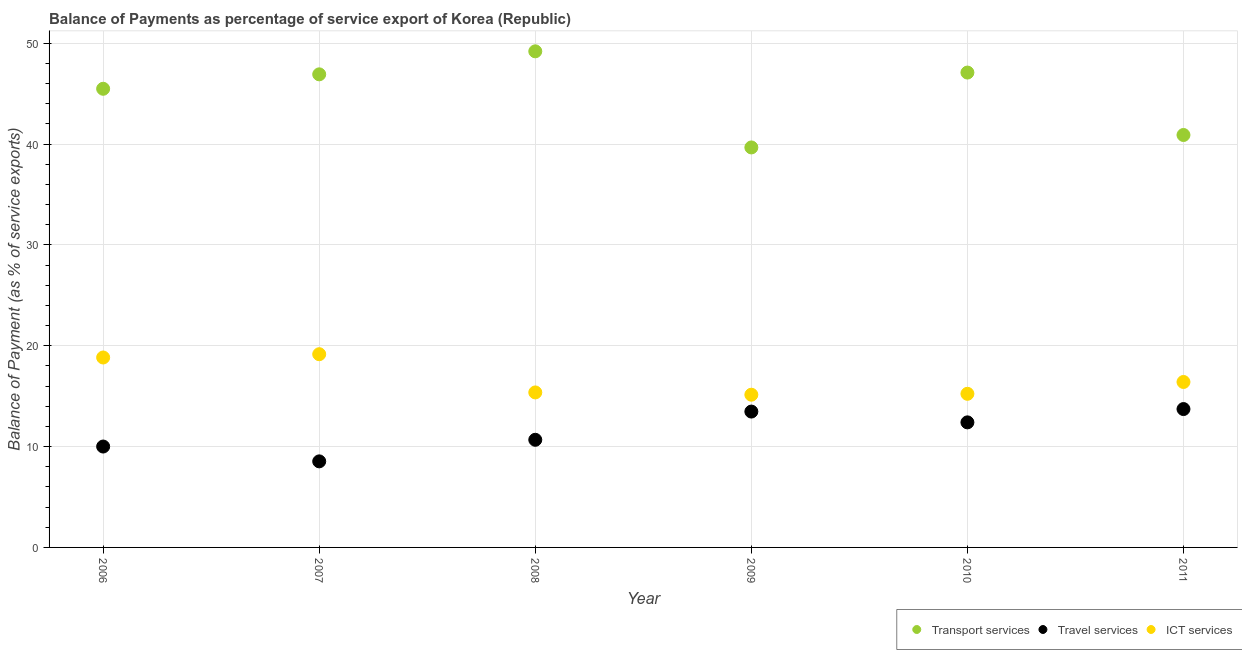How many different coloured dotlines are there?
Offer a terse response. 3. Is the number of dotlines equal to the number of legend labels?
Keep it short and to the point. Yes. What is the balance of payment of transport services in 2011?
Your answer should be compact. 40.91. Across all years, what is the maximum balance of payment of ict services?
Make the answer very short. 19.16. Across all years, what is the minimum balance of payment of ict services?
Your answer should be very brief. 15.15. In which year was the balance of payment of travel services maximum?
Ensure brevity in your answer.  2011. In which year was the balance of payment of ict services minimum?
Give a very brief answer. 2009. What is the total balance of payment of ict services in the graph?
Your answer should be compact. 100.17. What is the difference between the balance of payment of ict services in 2006 and that in 2008?
Give a very brief answer. 3.46. What is the difference between the balance of payment of travel services in 2006 and the balance of payment of ict services in 2009?
Give a very brief answer. -5.14. What is the average balance of payment of transport services per year?
Keep it short and to the point. 44.88. In the year 2010, what is the difference between the balance of payment of ict services and balance of payment of transport services?
Your answer should be very brief. -31.86. What is the ratio of the balance of payment of ict services in 2007 to that in 2009?
Provide a succinct answer. 1.27. Is the difference between the balance of payment of ict services in 2008 and 2010 greater than the difference between the balance of payment of travel services in 2008 and 2010?
Your response must be concise. Yes. What is the difference between the highest and the second highest balance of payment of travel services?
Make the answer very short. 0.25. What is the difference between the highest and the lowest balance of payment of travel services?
Provide a short and direct response. 5.19. Is the sum of the balance of payment of transport services in 2006 and 2009 greater than the maximum balance of payment of travel services across all years?
Give a very brief answer. Yes. Is it the case that in every year, the sum of the balance of payment of transport services and balance of payment of travel services is greater than the balance of payment of ict services?
Offer a very short reply. Yes. Is the balance of payment of ict services strictly greater than the balance of payment of transport services over the years?
Make the answer very short. No. Is the balance of payment of ict services strictly less than the balance of payment of travel services over the years?
Provide a succinct answer. No. How many years are there in the graph?
Offer a very short reply. 6. What is the difference between two consecutive major ticks on the Y-axis?
Your answer should be compact. 10. Are the values on the major ticks of Y-axis written in scientific E-notation?
Your answer should be very brief. No. Does the graph contain any zero values?
Offer a very short reply. No. Does the graph contain grids?
Offer a very short reply. Yes. Where does the legend appear in the graph?
Offer a terse response. Bottom right. How many legend labels are there?
Your answer should be compact. 3. How are the legend labels stacked?
Offer a terse response. Horizontal. What is the title of the graph?
Offer a very short reply. Balance of Payments as percentage of service export of Korea (Republic). Does "Oil" appear as one of the legend labels in the graph?
Your response must be concise. No. What is the label or title of the Y-axis?
Provide a succinct answer. Balance of Payment (as % of service exports). What is the Balance of Payment (as % of service exports) in Transport services in 2006?
Ensure brevity in your answer.  45.49. What is the Balance of Payment (as % of service exports) of Travel services in 2006?
Offer a very short reply. 10.01. What is the Balance of Payment (as % of service exports) in ICT services in 2006?
Provide a short and direct response. 18.84. What is the Balance of Payment (as % of service exports) of Transport services in 2007?
Provide a short and direct response. 46.92. What is the Balance of Payment (as % of service exports) of Travel services in 2007?
Ensure brevity in your answer.  8.54. What is the Balance of Payment (as % of service exports) in ICT services in 2007?
Your response must be concise. 19.16. What is the Balance of Payment (as % of service exports) of Transport services in 2008?
Provide a succinct answer. 49.21. What is the Balance of Payment (as % of service exports) of Travel services in 2008?
Ensure brevity in your answer.  10.68. What is the Balance of Payment (as % of service exports) of ICT services in 2008?
Offer a very short reply. 15.37. What is the Balance of Payment (as % of service exports) in Transport services in 2009?
Your answer should be very brief. 39.67. What is the Balance of Payment (as % of service exports) of Travel services in 2009?
Provide a short and direct response. 13.48. What is the Balance of Payment (as % of service exports) of ICT services in 2009?
Your answer should be compact. 15.15. What is the Balance of Payment (as % of service exports) of Transport services in 2010?
Ensure brevity in your answer.  47.1. What is the Balance of Payment (as % of service exports) of Travel services in 2010?
Your answer should be compact. 12.4. What is the Balance of Payment (as % of service exports) of ICT services in 2010?
Provide a succinct answer. 15.24. What is the Balance of Payment (as % of service exports) of Transport services in 2011?
Offer a very short reply. 40.91. What is the Balance of Payment (as % of service exports) of Travel services in 2011?
Offer a very short reply. 13.72. What is the Balance of Payment (as % of service exports) of ICT services in 2011?
Offer a terse response. 16.41. Across all years, what is the maximum Balance of Payment (as % of service exports) of Transport services?
Offer a terse response. 49.21. Across all years, what is the maximum Balance of Payment (as % of service exports) in Travel services?
Keep it short and to the point. 13.72. Across all years, what is the maximum Balance of Payment (as % of service exports) of ICT services?
Offer a terse response. 19.16. Across all years, what is the minimum Balance of Payment (as % of service exports) in Transport services?
Make the answer very short. 39.67. Across all years, what is the minimum Balance of Payment (as % of service exports) in Travel services?
Your answer should be very brief. 8.54. Across all years, what is the minimum Balance of Payment (as % of service exports) in ICT services?
Offer a terse response. 15.15. What is the total Balance of Payment (as % of service exports) of Transport services in the graph?
Offer a terse response. 269.3. What is the total Balance of Payment (as % of service exports) in Travel services in the graph?
Give a very brief answer. 68.82. What is the total Balance of Payment (as % of service exports) of ICT services in the graph?
Offer a terse response. 100.17. What is the difference between the Balance of Payment (as % of service exports) in Transport services in 2006 and that in 2007?
Offer a very short reply. -1.43. What is the difference between the Balance of Payment (as % of service exports) of Travel services in 2006 and that in 2007?
Provide a succinct answer. 1.47. What is the difference between the Balance of Payment (as % of service exports) in ICT services in 2006 and that in 2007?
Ensure brevity in your answer.  -0.33. What is the difference between the Balance of Payment (as % of service exports) of Transport services in 2006 and that in 2008?
Give a very brief answer. -3.71. What is the difference between the Balance of Payment (as % of service exports) in Travel services in 2006 and that in 2008?
Offer a very short reply. -0.67. What is the difference between the Balance of Payment (as % of service exports) of ICT services in 2006 and that in 2008?
Offer a very short reply. 3.46. What is the difference between the Balance of Payment (as % of service exports) in Transport services in 2006 and that in 2009?
Provide a short and direct response. 5.82. What is the difference between the Balance of Payment (as % of service exports) of Travel services in 2006 and that in 2009?
Your response must be concise. -3.47. What is the difference between the Balance of Payment (as % of service exports) in ICT services in 2006 and that in 2009?
Provide a succinct answer. 3.69. What is the difference between the Balance of Payment (as % of service exports) of Transport services in 2006 and that in 2010?
Your response must be concise. -1.61. What is the difference between the Balance of Payment (as % of service exports) of Travel services in 2006 and that in 2010?
Provide a succinct answer. -2.4. What is the difference between the Balance of Payment (as % of service exports) of ICT services in 2006 and that in 2010?
Ensure brevity in your answer.  3.6. What is the difference between the Balance of Payment (as % of service exports) of Transport services in 2006 and that in 2011?
Your answer should be compact. 4.58. What is the difference between the Balance of Payment (as % of service exports) of Travel services in 2006 and that in 2011?
Keep it short and to the point. -3.72. What is the difference between the Balance of Payment (as % of service exports) of ICT services in 2006 and that in 2011?
Your answer should be compact. 2.43. What is the difference between the Balance of Payment (as % of service exports) of Transport services in 2007 and that in 2008?
Give a very brief answer. -2.28. What is the difference between the Balance of Payment (as % of service exports) in Travel services in 2007 and that in 2008?
Offer a terse response. -2.14. What is the difference between the Balance of Payment (as % of service exports) in ICT services in 2007 and that in 2008?
Offer a terse response. 3.79. What is the difference between the Balance of Payment (as % of service exports) of Transport services in 2007 and that in 2009?
Offer a very short reply. 7.25. What is the difference between the Balance of Payment (as % of service exports) of Travel services in 2007 and that in 2009?
Your answer should be compact. -4.94. What is the difference between the Balance of Payment (as % of service exports) in ICT services in 2007 and that in 2009?
Your answer should be compact. 4.02. What is the difference between the Balance of Payment (as % of service exports) of Transport services in 2007 and that in 2010?
Your answer should be compact. -0.18. What is the difference between the Balance of Payment (as % of service exports) in Travel services in 2007 and that in 2010?
Offer a very short reply. -3.87. What is the difference between the Balance of Payment (as % of service exports) of ICT services in 2007 and that in 2010?
Ensure brevity in your answer.  3.93. What is the difference between the Balance of Payment (as % of service exports) in Transport services in 2007 and that in 2011?
Offer a terse response. 6.02. What is the difference between the Balance of Payment (as % of service exports) of Travel services in 2007 and that in 2011?
Your answer should be very brief. -5.19. What is the difference between the Balance of Payment (as % of service exports) of ICT services in 2007 and that in 2011?
Ensure brevity in your answer.  2.76. What is the difference between the Balance of Payment (as % of service exports) in Transport services in 2008 and that in 2009?
Give a very brief answer. 9.53. What is the difference between the Balance of Payment (as % of service exports) in Travel services in 2008 and that in 2009?
Your answer should be very brief. -2.8. What is the difference between the Balance of Payment (as % of service exports) of ICT services in 2008 and that in 2009?
Provide a short and direct response. 0.23. What is the difference between the Balance of Payment (as % of service exports) of Transport services in 2008 and that in 2010?
Your answer should be very brief. 2.11. What is the difference between the Balance of Payment (as % of service exports) of Travel services in 2008 and that in 2010?
Offer a terse response. -1.73. What is the difference between the Balance of Payment (as % of service exports) of ICT services in 2008 and that in 2010?
Provide a succinct answer. 0.14. What is the difference between the Balance of Payment (as % of service exports) in Transport services in 2008 and that in 2011?
Offer a very short reply. 8.3. What is the difference between the Balance of Payment (as % of service exports) of Travel services in 2008 and that in 2011?
Your answer should be compact. -3.05. What is the difference between the Balance of Payment (as % of service exports) of ICT services in 2008 and that in 2011?
Your answer should be compact. -1.04. What is the difference between the Balance of Payment (as % of service exports) in Transport services in 2009 and that in 2010?
Keep it short and to the point. -7.43. What is the difference between the Balance of Payment (as % of service exports) of Travel services in 2009 and that in 2010?
Make the answer very short. 1.07. What is the difference between the Balance of Payment (as % of service exports) in ICT services in 2009 and that in 2010?
Provide a succinct answer. -0.09. What is the difference between the Balance of Payment (as % of service exports) in Transport services in 2009 and that in 2011?
Your response must be concise. -1.23. What is the difference between the Balance of Payment (as % of service exports) of Travel services in 2009 and that in 2011?
Give a very brief answer. -0.25. What is the difference between the Balance of Payment (as % of service exports) of ICT services in 2009 and that in 2011?
Offer a terse response. -1.26. What is the difference between the Balance of Payment (as % of service exports) in Transport services in 2010 and that in 2011?
Your answer should be very brief. 6.19. What is the difference between the Balance of Payment (as % of service exports) of Travel services in 2010 and that in 2011?
Give a very brief answer. -1.32. What is the difference between the Balance of Payment (as % of service exports) of ICT services in 2010 and that in 2011?
Your response must be concise. -1.17. What is the difference between the Balance of Payment (as % of service exports) of Transport services in 2006 and the Balance of Payment (as % of service exports) of Travel services in 2007?
Offer a terse response. 36.96. What is the difference between the Balance of Payment (as % of service exports) in Transport services in 2006 and the Balance of Payment (as % of service exports) in ICT services in 2007?
Provide a succinct answer. 26.33. What is the difference between the Balance of Payment (as % of service exports) of Travel services in 2006 and the Balance of Payment (as % of service exports) of ICT services in 2007?
Provide a short and direct response. -9.16. What is the difference between the Balance of Payment (as % of service exports) of Transport services in 2006 and the Balance of Payment (as % of service exports) of Travel services in 2008?
Offer a very short reply. 34.82. What is the difference between the Balance of Payment (as % of service exports) of Transport services in 2006 and the Balance of Payment (as % of service exports) of ICT services in 2008?
Your answer should be very brief. 30.12. What is the difference between the Balance of Payment (as % of service exports) of Travel services in 2006 and the Balance of Payment (as % of service exports) of ICT services in 2008?
Offer a terse response. -5.37. What is the difference between the Balance of Payment (as % of service exports) of Transport services in 2006 and the Balance of Payment (as % of service exports) of Travel services in 2009?
Give a very brief answer. 32.02. What is the difference between the Balance of Payment (as % of service exports) of Transport services in 2006 and the Balance of Payment (as % of service exports) of ICT services in 2009?
Provide a short and direct response. 30.34. What is the difference between the Balance of Payment (as % of service exports) in Travel services in 2006 and the Balance of Payment (as % of service exports) in ICT services in 2009?
Offer a very short reply. -5.14. What is the difference between the Balance of Payment (as % of service exports) in Transport services in 2006 and the Balance of Payment (as % of service exports) in Travel services in 2010?
Offer a very short reply. 33.09. What is the difference between the Balance of Payment (as % of service exports) of Transport services in 2006 and the Balance of Payment (as % of service exports) of ICT services in 2010?
Offer a very short reply. 30.25. What is the difference between the Balance of Payment (as % of service exports) of Travel services in 2006 and the Balance of Payment (as % of service exports) of ICT services in 2010?
Your response must be concise. -5.23. What is the difference between the Balance of Payment (as % of service exports) in Transport services in 2006 and the Balance of Payment (as % of service exports) in Travel services in 2011?
Your answer should be very brief. 31.77. What is the difference between the Balance of Payment (as % of service exports) of Transport services in 2006 and the Balance of Payment (as % of service exports) of ICT services in 2011?
Your answer should be compact. 29.08. What is the difference between the Balance of Payment (as % of service exports) of Travel services in 2006 and the Balance of Payment (as % of service exports) of ICT services in 2011?
Provide a succinct answer. -6.4. What is the difference between the Balance of Payment (as % of service exports) of Transport services in 2007 and the Balance of Payment (as % of service exports) of Travel services in 2008?
Offer a very short reply. 36.25. What is the difference between the Balance of Payment (as % of service exports) in Transport services in 2007 and the Balance of Payment (as % of service exports) in ICT services in 2008?
Keep it short and to the point. 31.55. What is the difference between the Balance of Payment (as % of service exports) in Travel services in 2007 and the Balance of Payment (as % of service exports) in ICT services in 2008?
Make the answer very short. -6.84. What is the difference between the Balance of Payment (as % of service exports) of Transport services in 2007 and the Balance of Payment (as % of service exports) of Travel services in 2009?
Provide a short and direct response. 33.45. What is the difference between the Balance of Payment (as % of service exports) of Transport services in 2007 and the Balance of Payment (as % of service exports) of ICT services in 2009?
Ensure brevity in your answer.  31.78. What is the difference between the Balance of Payment (as % of service exports) of Travel services in 2007 and the Balance of Payment (as % of service exports) of ICT services in 2009?
Provide a succinct answer. -6.61. What is the difference between the Balance of Payment (as % of service exports) of Transport services in 2007 and the Balance of Payment (as % of service exports) of Travel services in 2010?
Give a very brief answer. 34.52. What is the difference between the Balance of Payment (as % of service exports) of Transport services in 2007 and the Balance of Payment (as % of service exports) of ICT services in 2010?
Provide a succinct answer. 31.69. What is the difference between the Balance of Payment (as % of service exports) of Travel services in 2007 and the Balance of Payment (as % of service exports) of ICT services in 2010?
Your answer should be very brief. -6.7. What is the difference between the Balance of Payment (as % of service exports) of Transport services in 2007 and the Balance of Payment (as % of service exports) of Travel services in 2011?
Provide a succinct answer. 33.2. What is the difference between the Balance of Payment (as % of service exports) in Transport services in 2007 and the Balance of Payment (as % of service exports) in ICT services in 2011?
Provide a short and direct response. 30.51. What is the difference between the Balance of Payment (as % of service exports) in Travel services in 2007 and the Balance of Payment (as % of service exports) in ICT services in 2011?
Keep it short and to the point. -7.87. What is the difference between the Balance of Payment (as % of service exports) of Transport services in 2008 and the Balance of Payment (as % of service exports) of Travel services in 2009?
Offer a very short reply. 35.73. What is the difference between the Balance of Payment (as % of service exports) of Transport services in 2008 and the Balance of Payment (as % of service exports) of ICT services in 2009?
Provide a short and direct response. 34.06. What is the difference between the Balance of Payment (as % of service exports) of Travel services in 2008 and the Balance of Payment (as % of service exports) of ICT services in 2009?
Your answer should be very brief. -4.47. What is the difference between the Balance of Payment (as % of service exports) of Transport services in 2008 and the Balance of Payment (as % of service exports) of Travel services in 2010?
Give a very brief answer. 36.8. What is the difference between the Balance of Payment (as % of service exports) of Transport services in 2008 and the Balance of Payment (as % of service exports) of ICT services in 2010?
Ensure brevity in your answer.  33.97. What is the difference between the Balance of Payment (as % of service exports) in Travel services in 2008 and the Balance of Payment (as % of service exports) in ICT services in 2010?
Offer a very short reply. -4.56. What is the difference between the Balance of Payment (as % of service exports) in Transport services in 2008 and the Balance of Payment (as % of service exports) in Travel services in 2011?
Your answer should be very brief. 35.48. What is the difference between the Balance of Payment (as % of service exports) of Transport services in 2008 and the Balance of Payment (as % of service exports) of ICT services in 2011?
Provide a succinct answer. 32.8. What is the difference between the Balance of Payment (as % of service exports) of Travel services in 2008 and the Balance of Payment (as % of service exports) of ICT services in 2011?
Offer a very short reply. -5.73. What is the difference between the Balance of Payment (as % of service exports) in Transport services in 2009 and the Balance of Payment (as % of service exports) in Travel services in 2010?
Provide a succinct answer. 27.27. What is the difference between the Balance of Payment (as % of service exports) of Transport services in 2009 and the Balance of Payment (as % of service exports) of ICT services in 2010?
Make the answer very short. 24.44. What is the difference between the Balance of Payment (as % of service exports) of Travel services in 2009 and the Balance of Payment (as % of service exports) of ICT services in 2010?
Make the answer very short. -1.76. What is the difference between the Balance of Payment (as % of service exports) in Transport services in 2009 and the Balance of Payment (as % of service exports) in Travel services in 2011?
Provide a succinct answer. 25.95. What is the difference between the Balance of Payment (as % of service exports) of Transport services in 2009 and the Balance of Payment (as % of service exports) of ICT services in 2011?
Provide a short and direct response. 23.26. What is the difference between the Balance of Payment (as % of service exports) in Travel services in 2009 and the Balance of Payment (as % of service exports) in ICT services in 2011?
Keep it short and to the point. -2.93. What is the difference between the Balance of Payment (as % of service exports) in Transport services in 2010 and the Balance of Payment (as % of service exports) in Travel services in 2011?
Provide a short and direct response. 33.38. What is the difference between the Balance of Payment (as % of service exports) in Transport services in 2010 and the Balance of Payment (as % of service exports) in ICT services in 2011?
Keep it short and to the point. 30.69. What is the difference between the Balance of Payment (as % of service exports) in Travel services in 2010 and the Balance of Payment (as % of service exports) in ICT services in 2011?
Your answer should be compact. -4.01. What is the average Balance of Payment (as % of service exports) of Transport services per year?
Your answer should be very brief. 44.88. What is the average Balance of Payment (as % of service exports) in Travel services per year?
Keep it short and to the point. 11.47. What is the average Balance of Payment (as % of service exports) in ICT services per year?
Keep it short and to the point. 16.7. In the year 2006, what is the difference between the Balance of Payment (as % of service exports) in Transport services and Balance of Payment (as % of service exports) in Travel services?
Keep it short and to the point. 35.48. In the year 2006, what is the difference between the Balance of Payment (as % of service exports) of Transport services and Balance of Payment (as % of service exports) of ICT services?
Keep it short and to the point. 26.65. In the year 2006, what is the difference between the Balance of Payment (as % of service exports) of Travel services and Balance of Payment (as % of service exports) of ICT services?
Keep it short and to the point. -8.83. In the year 2007, what is the difference between the Balance of Payment (as % of service exports) of Transport services and Balance of Payment (as % of service exports) of Travel services?
Your answer should be very brief. 38.39. In the year 2007, what is the difference between the Balance of Payment (as % of service exports) of Transport services and Balance of Payment (as % of service exports) of ICT services?
Ensure brevity in your answer.  27.76. In the year 2007, what is the difference between the Balance of Payment (as % of service exports) of Travel services and Balance of Payment (as % of service exports) of ICT services?
Ensure brevity in your answer.  -10.63. In the year 2008, what is the difference between the Balance of Payment (as % of service exports) in Transport services and Balance of Payment (as % of service exports) in Travel services?
Ensure brevity in your answer.  38.53. In the year 2008, what is the difference between the Balance of Payment (as % of service exports) of Transport services and Balance of Payment (as % of service exports) of ICT services?
Your answer should be very brief. 33.83. In the year 2008, what is the difference between the Balance of Payment (as % of service exports) of Travel services and Balance of Payment (as % of service exports) of ICT services?
Provide a short and direct response. -4.7. In the year 2009, what is the difference between the Balance of Payment (as % of service exports) of Transport services and Balance of Payment (as % of service exports) of Travel services?
Make the answer very short. 26.2. In the year 2009, what is the difference between the Balance of Payment (as % of service exports) of Transport services and Balance of Payment (as % of service exports) of ICT services?
Provide a succinct answer. 24.53. In the year 2009, what is the difference between the Balance of Payment (as % of service exports) in Travel services and Balance of Payment (as % of service exports) in ICT services?
Offer a terse response. -1.67. In the year 2010, what is the difference between the Balance of Payment (as % of service exports) in Transport services and Balance of Payment (as % of service exports) in Travel services?
Provide a short and direct response. 34.7. In the year 2010, what is the difference between the Balance of Payment (as % of service exports) of Transport services and Balance of Payment (as % of service exports) of ICT services?
Provide a succinct answer. 31.86. In the year 2010, what is the difference between the Balance of Payment (as % of service exports) in Travel services and Balance of Payment (as % of service exports) in ICT services?
Keep it short and to the point. -2.83. In the year 2011, what is the difference between the Balance of Payment (as % of service exports) of Transport services and Balance of Payment (as % of service exports) of Travel services?
Your response must be concise. 27.18. In the year 2011, what is the difference between the Balance of Payment (as % of service exports) of Transport services and Balance of Payment (as % of service exports) of ICT services?
Make the answer very short. 24.5. In the year 2011, what is the difference between the Balance of Payment (as % of service exports) of Travel services and Balance of Payment (as % of service exports) of ICT services?
Your response must be concise. -2.69. What is the ratio of the Balance of Payment (as % of service exports) in Transport services in 2006 to that in 2007?
Your response must be concise. 0.97. What is the ratio of the Balance of Payment (as % of service exports) of Travel services in 2006 to that in 2007?
Ensure brevity in your answer.  1.17. What is the ratio of the Balance of Payment (as % of service exports) of ICT services in 2006 to that in 2007?
Provide a short and direct response. 0.98. What is the ratio of the Balance of Payment (as % of service exports) in Transport services in 2006 to that in 2008?
Your answer should be very brief. 0.92. What is the ratio of the Balance of Payment (as % of service exports) of Travel services in 2006 to that in 2008?
Ensure brevity in your answer.  0.94. What is the ratio of the Balance of Payment (as % of service exports) in ICT services in 2006 to that in 2008?
Provide a succinct answer. 1.23. What is the ratio of the Balance of Payment (as % of service exports) in Transport services in 2006 to that in 2009?
Provide a short and direct response. 1.15. What is the ratio of the Balance of Payment (as % of service exports) of Travel services in 2006 to that in 2009?
Provide a short and direct response. 0.74. What is the ratio of the Balance of Payment (as % of service exports) of ICT services in 2006 to that in 2009?
Your answer should be very brief. 1.24. What is the ratio of the Balance of Payment (as % of service exports) in Transport services in 2006 to that in 2010?
Offer a very short reply. 0.97. What is the ratio of the Balance of Payment (as % of service exports) in Travel services in 2006 to that in 2010?
Offer a terse response. 0.81. What is the ratio of the Balance of Payment (as % of service exports) in ICT services in 2006 to that in 2010?
Ensure brevity in your answer.  1.24. What is the ratio of the Balance of Payment (as % of service exports) of Transport services in 2006 to that in 2011?
Offer a very short reply. 1.11. What is the ratio of the Balance of Payment (as % of service exports) in Travel services in 2006 to that in 2011?
Keep it short and to the point. 0.73. What is the ratio of the Balance of Payment (as % of service exports) of ICT services in 2006 to that in 2011?
Offer a very short reply. 1.15. What is the ratio of the Balance of Payment (as % of service exports) of Transport services in 2007 to that in 2008?
Offer a very short reply. 0.95. What is the ratio of the Balance of Payment (as % of service exports) in Travel services in 2007 to that in 2008?
Ensure brevity in your answer.  0.8. What is the ratio of the Balance of Payment (as % of service exports) of ICT services in 2007 to that in 2008?
Ensure brevity in your answer.  1.25. What is the ratio of the Balance of Payment (as % of service exports) in Transport services in 2007 to that in 2009?
Keep it short and to the point. 1.18. What is the ratio of the Balance of Payment (as % of service exports) of Travel services in 2007 to that in 2009?
Offer a very short reply. 0.63. What is the ratio of the Balance of Payment (as % of service exports) of ICT services in 2007 to that in 2009?
Ensure brevity in your answer.  1.27. What is the ratio of the Balance of Payment (as % of service exports) of Travel services in 2007 to that in 2010?
Your answer should be compact. 0.69. What is the ratio of the Balance of Payment (as % of service exports) of ICT services in 2007 to that in 2010?
Offer a very short reply. 1.26. What is the ratio of the Balance of Payment (as % of service exports) of Transport services in 2007 to that in 2011?
Your answer should be compact. 1.15. What is the ratio of the Balance of Payment (as % of service exports) in Travel services in 2007 to that in 2011?
Offer a very short reply. 0.62. What is the ratio of the Balance of Payment (as % of service exports) of ICT services in 2007 to that in 2011?
Offer a very short reply. 1.17. What is the ratio of the Balance of Payment (as % of service exports) of Transport services in 2008 to that in 2009?
Your answer should be compact. 1.24. What is the ratio of the Balance of Payment (as % of service exports) in Travel services in 2008 to that in 2009?
Ensure brevity in your answer.  0.79. What is the ratio of the Balance of Payment (as % of service exports) of ICT services in 2008 to that in 2009?
Offer a terse response. 1.01. What is the ratio of the Balance of Payment (as % of service exports) in Transport services in 2008 to that in 2010?
Offer a very short reply. 1.04. What is the ratio of the Balance of Payment (as % of service exports) in Travel services in 2008 to that in 2010?
Your response must be concise. 0.86. What is the ratio of the Balance of Payment (as % of service exports) of Transport services in 2008 to that in 2011?
Provide a short and direct response. 1.2. What is the ratio of the Balance of Payment (as % of service exports) of Travel services in 2008 to that in 2011?
Give a very brief answer. 0.78. What is the ratio of the Balance of Payment (as % of service exports) in ICT services in 2008 to that in 2011?
Your answer should be very brief. 0.94. What is the ratio of the Balance of Payment (as % of service exports) of Transport services in 2009 to that in 2010?
Make the answer very short. 0.84. What is the ratio of the Balance of Payment (as % of service exports) of Travel services in 2009 to that in 2010?
Give a very brief answer. 1.09. What is the ratio of the Balance of Payment (as % of service exports) of ICT services in 2009 to that in 2010?
Offer a very short reply. 0.99. What is the ratio of the Balance of Payment (as % of service exports) in Transport services in 2009 to that in 2011?
Ensure brevity in your answer.  0.97. What is the ratio of the Balance of Payment (as % of service exports) in Travel services in 2009 to that in 2011?
Your response must be concise. 0.98. What is the ratio of the Balance of Payment (as % of service exports) in ICT services in 2009 to that in 2011?
Your response must be concise. 0.92. What is the ratio of the Balance of Payment (as % of service exports) of Transport services in 2010 to that in 2011?
Provide a short and direct response. 1.15. What is the ratio of the Balance of Payment (as % of service exports) of Travel services in 2010 to that in 2011?
Offer a very short reply. 0.9. What is the ratio of the Balance of Payment (as % of service exports) in ICT services in 2010 to that in 2011?
Your answer should be compact. 0.93. What is the difference between the highest and the second highest Balance of Payment (as % of service exports) of Transport services?
Offer a terse response. 2.11. What is the difference between the highest and the second highest Balance of Payment (as % of service exports) of Travel services?
Provide a short and direct response. 0.25. What is the difference between the highest and the second highest Balance of Payment (as % of service exports) in ICT services?
Make the answer very short. 0.33. What is the difference between the highest and the lowest Balance of Payment (as % of service exports) in Transport services?
Offer a very short reply. 9.53. What is the difference between the highest and the lowest Balance of Payment (as % of service exports) of Travel services?
Offer a terse response. 5.19. What is the difference between the highest and the lowest Balance of Payment (as % of service exports) of ICT services?
Your answer should be compact. 4.02. 